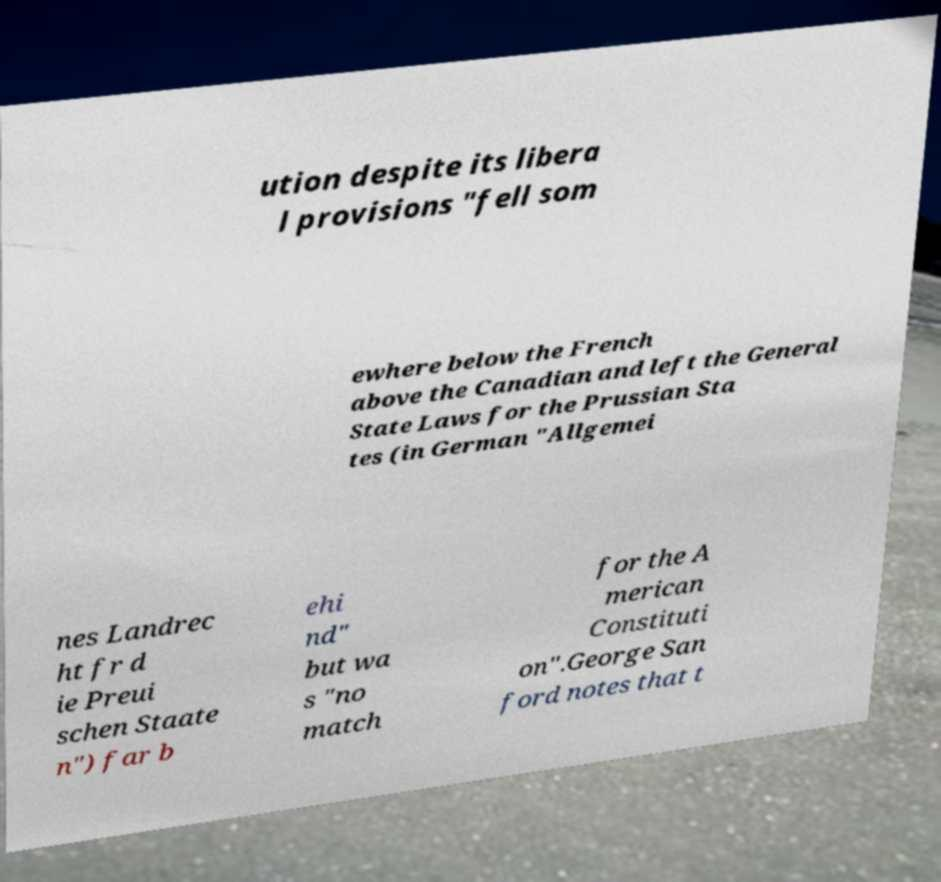For documentation purposes, I need the text within this image transcribed. Could you provide that? ution despite its libera l provisions "fell som ewhere below the French above the Canadian and left the General State Laws for the Prussian Sta tes (in German "Allgemei nes Landrec ht fr d ie Preui schen Staate n") far b ehi nd" but wa s "no match for the A merican Constituti on".George San ford notes that t 